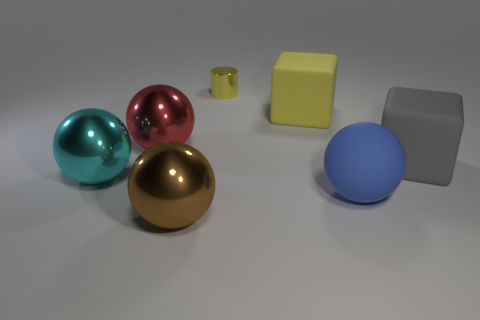Subtract all shiny spheres. How many spheres are left? 1 Add 1 large yellow cylinders. How many objects exist? 8 Subtract 1 cubes. How many cubes are left? 1 Subtract all cylinders. How many objects are left? 6 Subtract all gray blocks. Subtract all large red matte cubes. How many objects are left? 6 Add 5 big gray objects. How many big gray objects are left? 6 Add 3 large cyan spheres. How many large cyan spheres exist? 4 Subtract all red spheres. How many spheres are left? 3 Subtract 0 gray balls. How many objects are left? 7 Subtract all brown cylinders. Subtract all green balls. How many cylinders are left? 1 